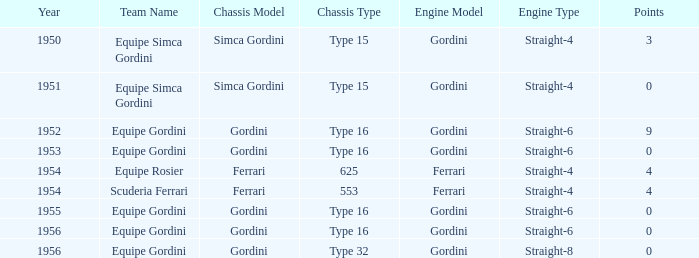How many points after 1956? 0.0. 